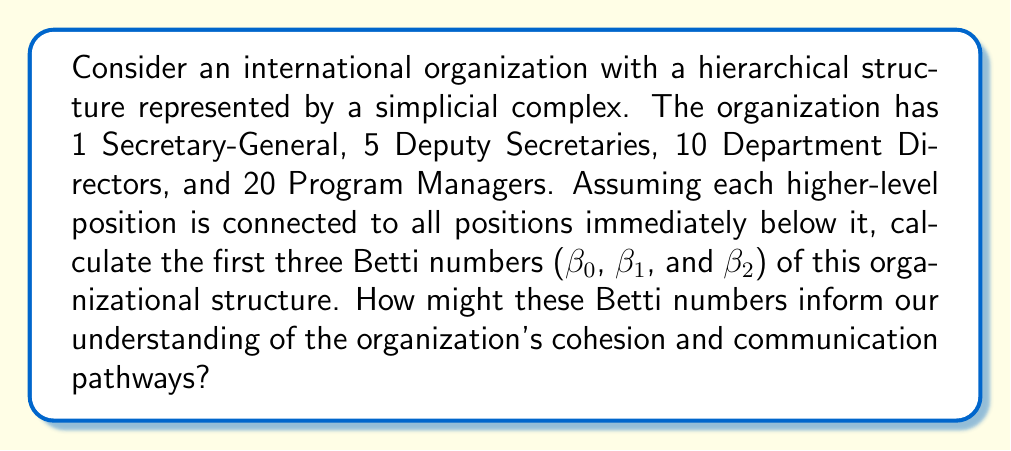Give your solution to this math problem. To solve this problem, we need to understand the concept of simplicial complexes and how they relate to organizational hierarchies. Then, we'll calculate the Betti numbers using the alternating sum formula.

1. Constructing the simplicial complex:
   - 0-simplices: 1 + 5 + 10 + 20 = 36 vertices (all positions)
   - 1-simplices: (1 × 5) + (5 × 10) + (10 × 20) = 255 edges (connections between adjacent levels)
   - 2-simplices: (1 × 5 × 10) + (5 × 10 × 20) = 1050 triangles
   - 3-simplices: 1 × 5 × 10 × 20 = 1000 tetrahedra

2. Calculating Betti numbers:
   Let $\chi$ be the Euler characteristic, and $f_i$ be the number of $i$-simplices.
   
   $$\chi = \sum_{i=0}^{\infty} (-1)^i f_i = f_0 - f_1 + f_2 - f_3 + \cdots$$
   
   $$\chi = 36 - 255 + 1050 - 1000 = -169$$
   
   The alternating sum formula for Betti numbers is:
   
   $$\chi = \sum_{i=0}^{\infty} (-1)^i \beta_i$$
   
   We know that $\beta_0 = 1$ (the complex is connected), and $\beta_i = 0$ for $i \geq 3$ (no higher-dimensional holes). So:
   
   $$-169 = 1 - \beta_1 + \beta_2$$
   
   $$\beta_2 - \beta_1 = -170$$

3. Interpreting the results:
   - $\beta_0 = 1$: The organization is connected, with a single component.
   - $\beta_1$: Represents the number of independent cycles or loops in the structure.
   - $\beta_2$: Represents the number of voids or cavities in the structure.

   We can't determine exact values for $\beta_1$ and $\beta_2$ without more information, but we know their difference is 170.

4. Implications for organizational structure:
   - A low $\beta_1$ suggests few alternative communication pathways, indicating a more rigid hierarchy.
   - A high $\beta_2$ suggests the presence of structural holes or gaps in the organization, potentially indicating areas where communication or coordination might be lacking.

The exact values of $\beta_1$ and $\beta_2$ would provide more specific insights into the organization's structure and potential areas for improvement in communication and cohesion.
Answer: $\beta_0 = 1$, $\beta_2 - \beta_1 = -170$. The exact values of $\beta_1$ and $\beta_2$ cannot be determined without additional information, but their relationship provides insights into the organization's structure, communication pathways, and potential areas for improving cohesion. 